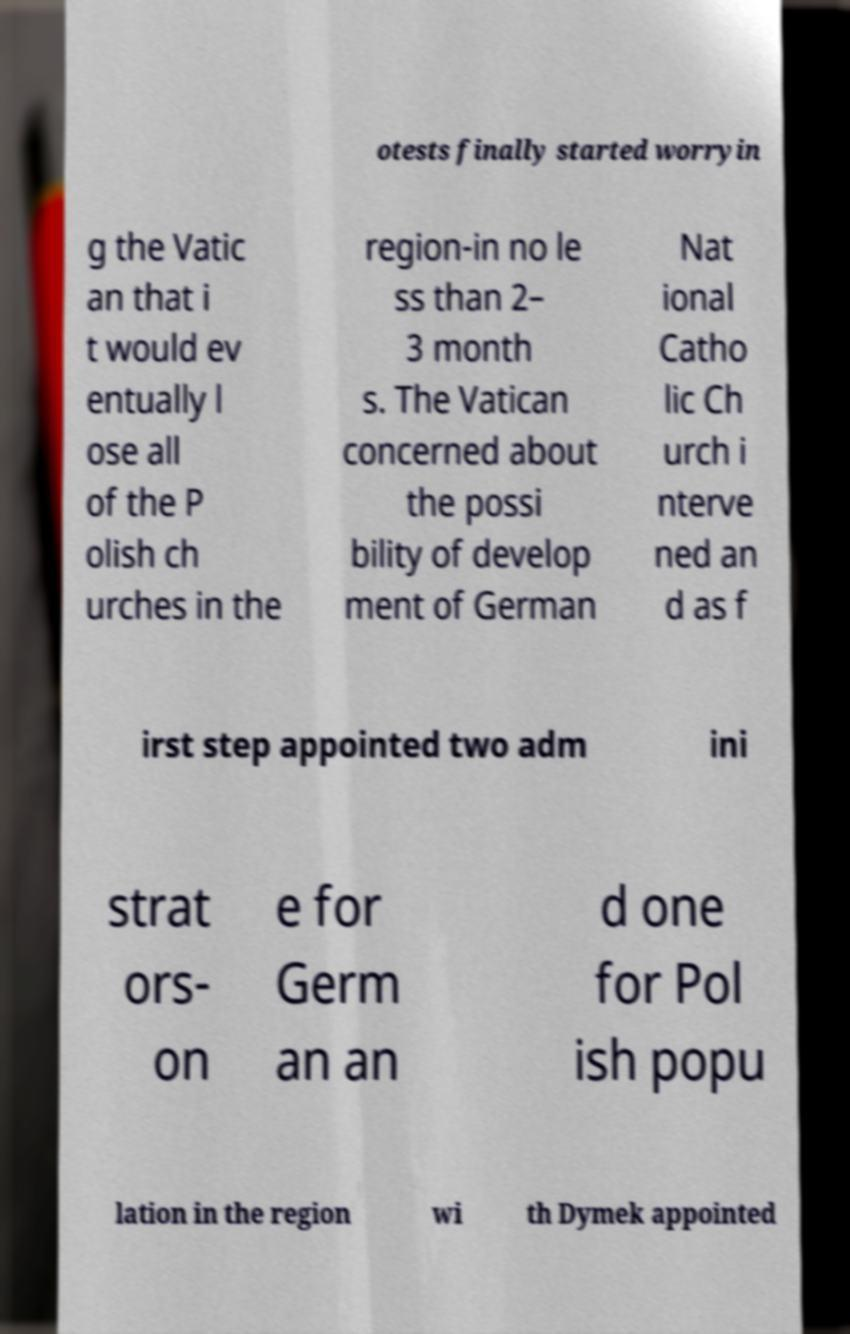What messages or text are displayed in this image? I need them in a readable, typed format. otests finally started worryin g the Vatic an that i t would ev entually l ose all of the P olish ch urches in the region-in no le ss than 2– 3 month s. The Vatican concerned about the possi bility of develop ment of German Nat ional Catho lic Ch urch i nterve ned an d as f irst step appointed two adm ini strat ors- on e for Germ an an d one for Pol ish popu lation in the region wi th Dymek appointed 